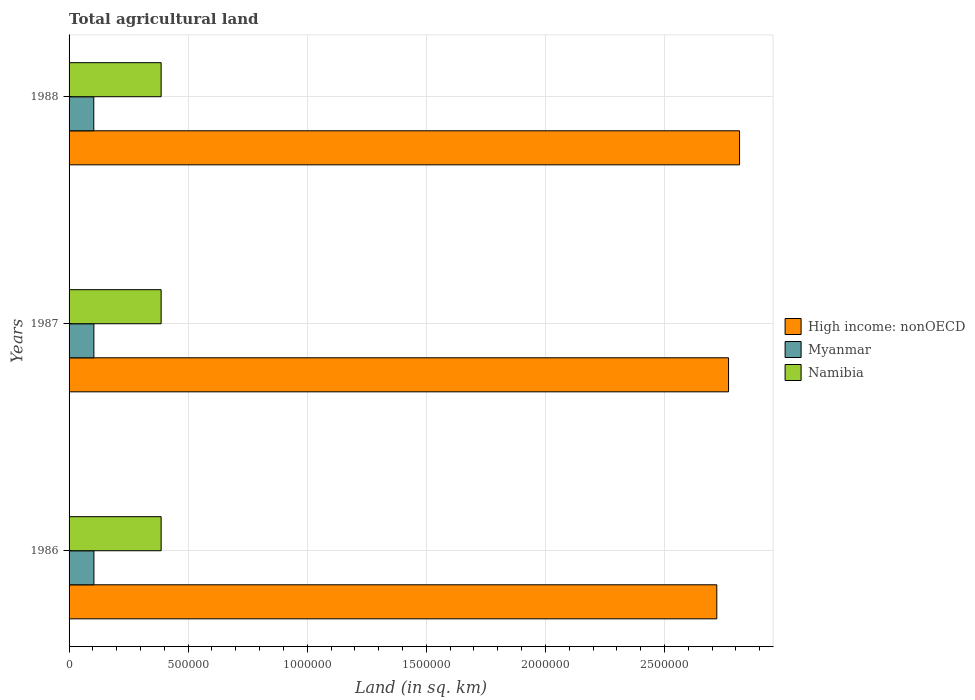Are the number of bars on each tick of the Y-axis equal?
Provide a succinct answer. Yes. How many bars are there on the 3rd tick from the bottom?
Your answer should be very brief. 3. What is the label of the 1st group of bars from the top?
Provide a succinct answer. 1988. What is the total agricultural land in Myanmar in 1987?
Your response must be concise. 1.04e+05. Across all years, what is the maximum total agricultural land in High income: nonOECD?
Your answer should be very brief. 2.82e+06. Across all years, what is the minimum total agricultural land in Myanmar?
Give a very brief answer. 1.04e+05. In which year was the total agricultural land in High income: nonOECD maximum?
Ensure brevity in your answer.  1988. In which year was the total agricultural land in Namibia minimum?
Give a very brief answer. 1986. What is the total total agricultural land in Myanmar in the graph?
Your answer should be compact. 3.12e+05. What is the difference between the total agricultural land in Myanmar in 1986 and that in 1987?
Give a very brief answer. 130. What is the difference between the total agricultural land in High income: nonOECD in 1987 and the total agricultural land in Myanmar in 1988?
Offer a terse response. 2.67e+06. What is the average total agricultural land in Namibia per year?
Make the answer very short. 3.87e+05. In the year 1988, what is the difference between the total agricultural land in Myanmar and total agricultural land in High income: nonOECD?
Provide a short and direct response. -2.71e+06. In how many years, is the total agricultural land in Namibia greater than 1000000 sq.km?
Provide a short and direct response. 0. What is the ratio of the total agricultural land in High income: nonOECD in 1986 to that in 1988?
Offer a very short reply. 0.97. Is the total agricultural land in Namibia in 1986 less than that in 1987?
Provide a succinct answer. No. What is the difference between the highest and the second highest total agricultural land in High income: nonOECD?
Provide a succinct answer. 4.63e+04. What is the difference between the highest and the lowest total agricultural land in Myanmar?
Keep it short and to the point. 620. In how many years, is the total agricultural land in Namibia greater than the average total agricultural land in Namibia taken over all years?
Offer a very short reply. 0. Is the sum of the total agricultural land in Myanmar in 1986 and 1987 greater than the maximum total agricultural land in Namibia across all years?
Provide a succinct answer. No. What does the 2nd bar from the top in 1987 represents?
Provide a short and direct response. Myanmar. What does the 3rd bar from the bottom in 1988 represents?
Your response must be concise. Namibia. Is it the case that in every year, the sum of the total agricultural land in Namibia and total agricultural land in High income: nonOECD is greater than the total agricultural land in Myanmar?
Your answer should be very brief. Yes. How many years are there in the graph?
Ensure brevity in your answer.  3. What is the difference between two consecutive major ticks on the X-axis?
Your response must be concise. 5.00e+05. Are the values on the major ticks of X-axis written in scientific E-notation?
Offer a very short reply. No. Does the graph contain any zero values?
Provide a short and direct response. No. Does the graph contain grids?
Make the answer very short. Yes. What is the title of the graph?
Offer a very short reply. Total agricultural land. What is the label or title of the X-axis?
Offer a very short reply. Land (in sq. km). What is the label or title of the Y-axis?
Ensure brevity in your answer.  Years. What is the Land (in sq. km) in High income: nonOECD in 1986?
Give a very brief answer. 2.72e+06. What is the Land (in sq. km) in Myanmar in 1986?
Keep it short and to the point. 1.04e+05. What is the Land (in sq. km) in Namibia in 1986?
Your answer should be very brief. 3.87e+05. What is the Land (in sq. km) of High income: nonOECD in 1987?
Offer a very short reply. 2.77e+06. What is the Land (in sq. km) in Myanmar in 1987?
Provide a short and direct response. 1.04e+05. What is the Land (in sq. km) in Namibia in 1987?
Ensure brevity in your answer.  3.87e+05. What is the Land (in sq. km) in High income: nonOECD in 1988?
Give a very brief answer. 2.82e+06. What is the Land (in sq. km) of Myanmar in 1988?
Your answer should be compact. 1.04e+05. What is the Land (in sq. km) in Namibia in 1988?
Ensure brevity in your answer.  3.87e+05. Across all years, what is the maximum Land (in sq. km) in High income: nonOECD?
Your answer should be compact. 2.82e+06. Across all years, what is the maximum Land (in sq. km) in Myanmar?
Offer a terse response. 1.04e+05. Across all years, what is the maximum Land (in sq. km) of Namibia?
Your answer should be very brief. 3.87e+05. Across all years, what is the minimum Land (in sq. km) in High income: nonOECD?
Provide a short and direct response. 2.72e+06. Across all years, what is the minimum Land (in sq. km) of Myanmar?
Ensure brevity in your answer.  1.04e+05. Across all years, what is the minimum Land (in sq. km) of Namibia?
Your answer should be very brief. 3.87e+05. What is the total Land (in sq. km) in High income: nonOECD in the graph?
Keep it short and to the point. 8.30e+06. What is the total Land (in sq. km) of Myanmar in the graph?
Give a very brief answer. 3.12e+05. What is the total Land (in sq. km) in Namibia in the graph?
Make the answer very short. 1.16e+06. What is the difference between the Land (in sq. km) in High income: nonOECD in 1986 and that in 1987?
Your response must be concise. -4.93e+04. What is the difference between the Land (in sq. km) of Myanmar in 1986 and that in 1987?
Offer a very short reply. 130. What is the difference between the Land (in sq. km) of High income: nonOECD in 1986 and that in 1988?
Your answer should be very brief. -9.56e+04. What is the difference between the Land (in sq. km) in Myanmar in 1986 and that in 1988?
Provide a succinct answer. 620. What is the difference between the Land (in sq. km) of High income: nonOECD in 1987 and that in 1988?
Your answer should be very brief. -4.63e+04. What is the difference between the Land (in sq. km) of Myanmar in 1987 and that in 1988?
Your answer should be very brief. 490. What is the difference between the Land (in sq. km) in High income: nonOECD in 1986 and the Land (in sq. km) in Myanmar in 1987?
Give a very brief answer. 2.62e+06. What is the difference between the Land (in sq. km) in High income: nonOECD in 1986 and the Land (in sq. km) in Namibia in 1987?
Offer a terse response. 2.33e+06. What is the difference between the Land (in sq. km) of Myanmar in 1986 and the Land (in sq. km) of Namibia in 1987?
Your answer should be compact. -2.82e+05. What is the difference between the Land (in sq. km) of High income: nonOECD in 1986 and the Land (in sq. km) of Myanmar in 1988?
Provide a succinct answer. 2.62e+06. What is the difference between the Land (in sq. km) of High income: nonOECD in 1986 and the Land (in sq. km) of Namibia in 1988?
Your answer should be compact. 2.33e+06. What is the difference between the Land (in sq. km) of Myanmar in 1986 and the Land (in sq. km) of Namibia in 1988?
Make the answer very short. -2.82e+05. What is the difference between the Land (in sq. km) of High income: nonOECD in 1987 and the Land (in sq. km) of Myanmar in 1988?
Your answer should be compact. 2.67e+06. What is the difference between the Land (in sq. km) of High income: nonOECD in 1987 and the Land (in sq. km) of Namibia in 1988?
Your answer should be very brief. 2.38e+06. What is the difference between the Land (in sq. km) in Myanmar in 1987 and the Land (in sq. km) in Namibia in 1988?
Keep it short and to the point. -2.82e+05. What is the average Land (in sq. km) of High income: nonOECD per year?
Offer a very short reply. 2.77e+06. What is the average Land (in sq. km) of Myanmar per year?
Offer a very short reply. 1.04e+05. What is the average Land (in sq. km) of Namibia per year?
Provide a short and direct response. 3.87e+05. In the year 1986, what is the difference between the Land (in sq. km) of High income: nonOECD and Land (in sq. km) of Myanmar?
Provide a short and direct response. 2.62e+06. In the year 1986, what is the difference between the Land (in sq. km) of High income: nonOECD and Land (in sq. km) of Namibia?
Keep it short and to the point. 2.33e+06. In the year 1986, what is the difference between the Land (in sq. km) of Myanmar and Land (in sq. km) of Namibia?
Keep it short and to the point. -2.82e+05. In the year 1987, what is the difference between the Land (in sq. km) of High income: nonOECD and Land (in sq. km) of Myanmar?
Your response must be concise. 2.66e+06. In the year 1987, what is the difference between the Land (in sq. km) in High income: nonOECD and Land (in sq. km) in Namibia?
Give a very brief answer. 2.38e+06. In the year 1987, what is the difference between the Land (in sq. km) in Myanmar and Land (in sq. km) in Namibia?
Keep it short and to the point. -2.82e+05. In the year 1988, what is the difference between the Land (in sq. km) of High income: nonOECD and Land (in sq. km) of Myanmar?
Offer a very short reply. 2.71e+06. In the year 1988, what is the difference between the Land (in sq. km) in High income: nonOECD and Land (in sq. km) in Namibia?
Keep it short and to the point. 2.43e+06. In the year 1988, what is the difference between the Land (in sq. km) in Myanmar and Land (in sq. km) in Namibia?
Offer a terse response. -2.83e+05. What is the ratio of the Land (in sq. km) in High income: nonOECD in 1986 to that in 1987?
Offer a terse response. 0.98. What is the ratio of the Land (in sq. km) in Myanmar in 1986 to that in 1987?
Give a very brief answer. 1. What is the ratio of the Land (in sq. km) in Namibia in 1986 to that in 1987?
Offer a very short reply. 1. What is the ratio of the Land (in sq. km) in High income: nonOECD in 1987 to that in 1988?
Make the answer very short. 0.98. What is the difference between the highest and the second highest Land (in sq. km) of High income: nonOECD?
Make the answer very short. 4.63e+04. What is the difference between the highest and the second highest Land (in sq. km) of Myanmar?
Your answer should be compact. 130. What is the difference between the highest and the second highest Land (in sq. km) in Namibia?
Your answer should be very brief. 0. What is the difference between the highest and the lowest Land (in sq. km) of High income: nonOECD?
Make the answer very short. 9.56e+04. What is the difference between the highest and the lowest Land (in sq. km) in Myanmar?
Offer a terse response. 620. 